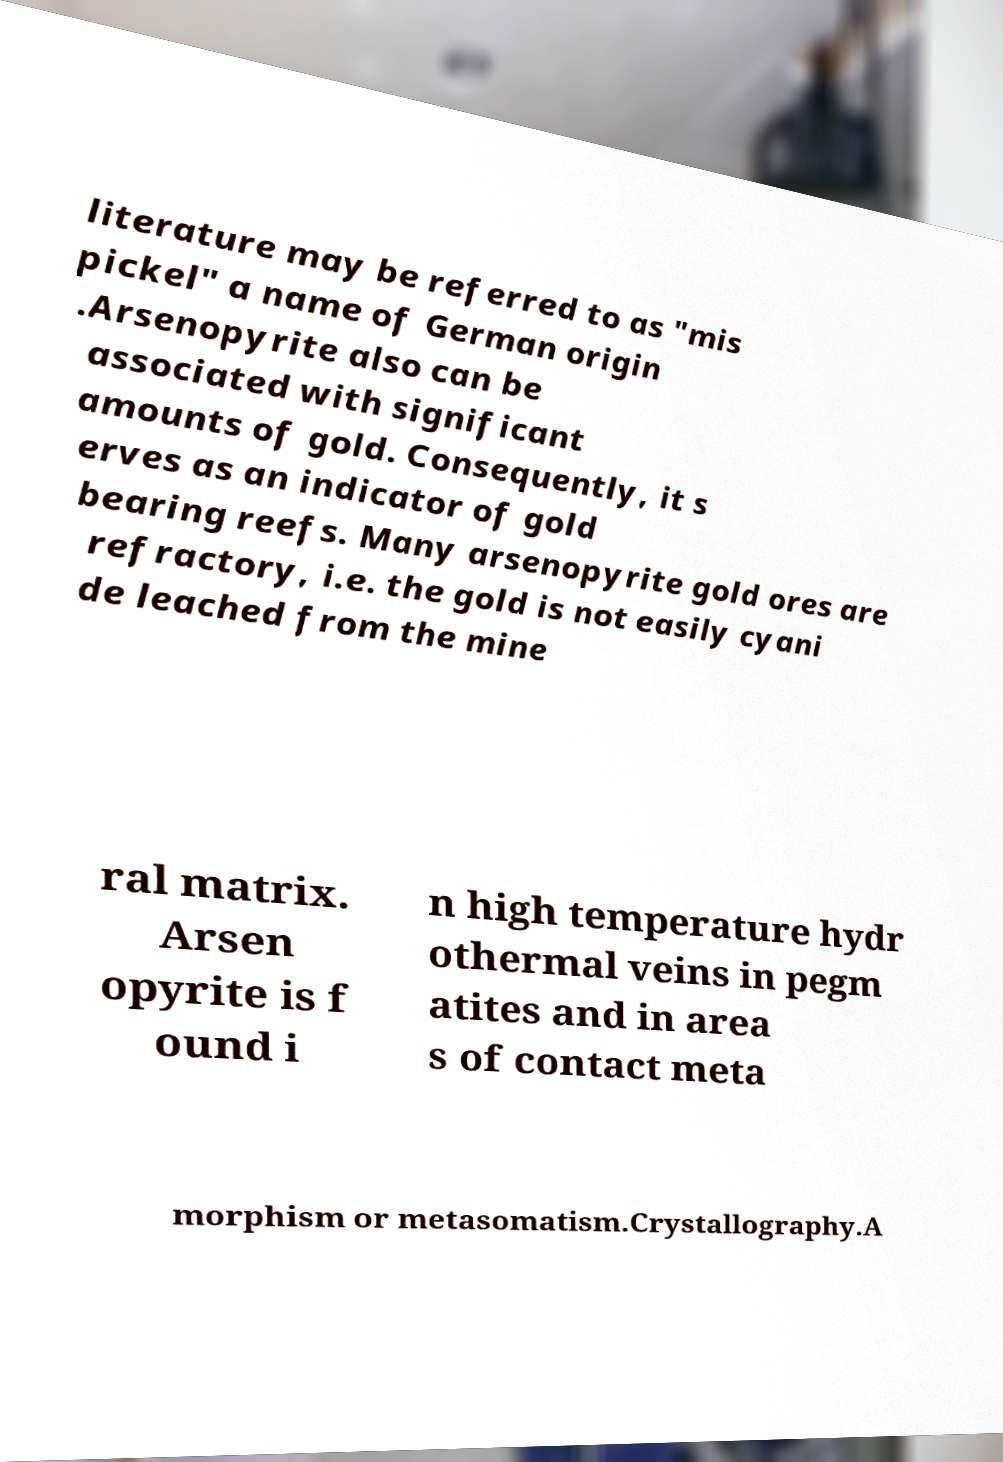What messages or text are displayed in this image? I need them in a readable, typed format. literature may be referred to as "mis pickel" a name of German origin .Arsenopyrite also can be associated with significant amounts of gold. Consequently, it s erves as an indicator of gold bearing reefs. Many arsenopyrite gold ores are refractory, i.e. the gold is not easily cyani de leached from the mine ral matrix. Arsen opyrite is f ound i n high temperature hydr othermal veins in pegm atites and in area s of contact meta morphism or metasomatism.Crystallography.A 